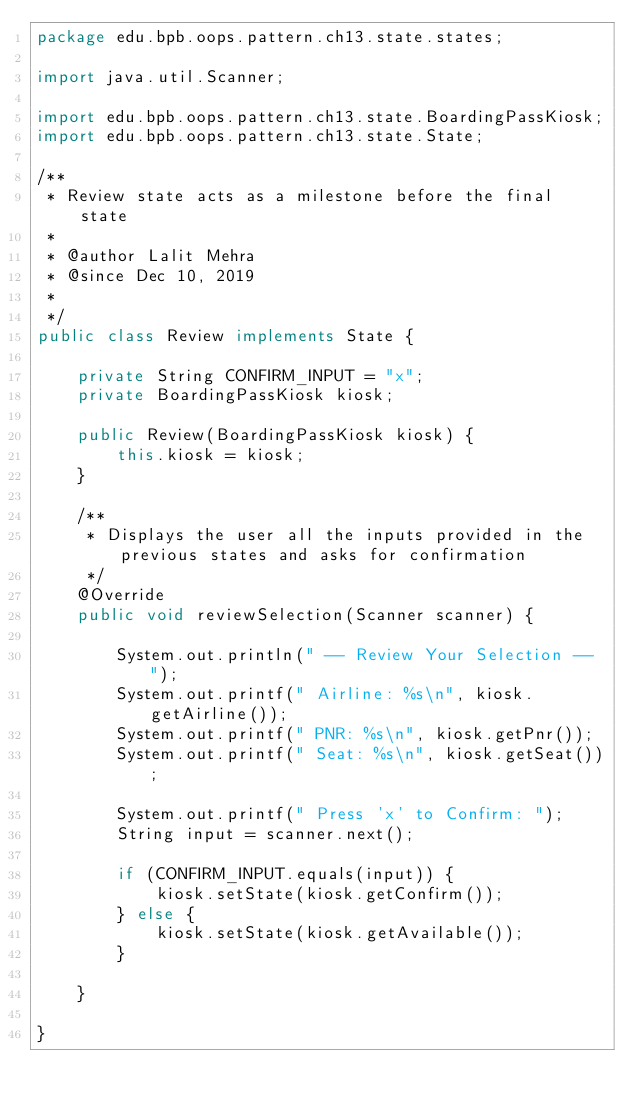<code> <loc_0><loc_0><loc_500><loc_500><_Java_>package edu.bpb.oops.pattern.ch13.state.states;

import java.util.Scanner;

import edu.bpb.oops.pattern.ch13.state.BoardingPassKiosk;
import edu.bpb.oops.pattern.ch13.state.State;

/**
 * Review state acts as a milestone before the final state 
 * 
 * @author Lalit Mehra
 * @since Dec 10, 2019
 *
 */
public class Review implements State {

	private String CONFIRM_INPUT = "x";
	private BoardingPassKiosk kiosk;

	public Review(BoardingPassKiosk kiosk) {
		this.kiosk = kiosk;
	}

	/**
	 * Displays the user all the inputs provided in the previous states and asks for confirmation
	 */
	@Override
	public void reviewSelection(Scanner scanner) {

		System.out.println(" -- Review Your Selection -- ");
		System.out.printf(" Airline: %s\n", kiosk.getAirline());
		System.out.printf(" PNR: %s\n", kiosk.getPnr());
		System.out.printf(" Seat: %s\n", kiosk.getSeat());

		System.out.printf(" Press 'x' to Confirm: ");
		String input = scanner.next();

		if (CONFIRM_INPUT.equals(input)) {
			kiosk.setState(kiosk.getConfirm());
		} else {
			kiosk.setState(kiosk.getAvailable());
		}

	}

}
</code> 